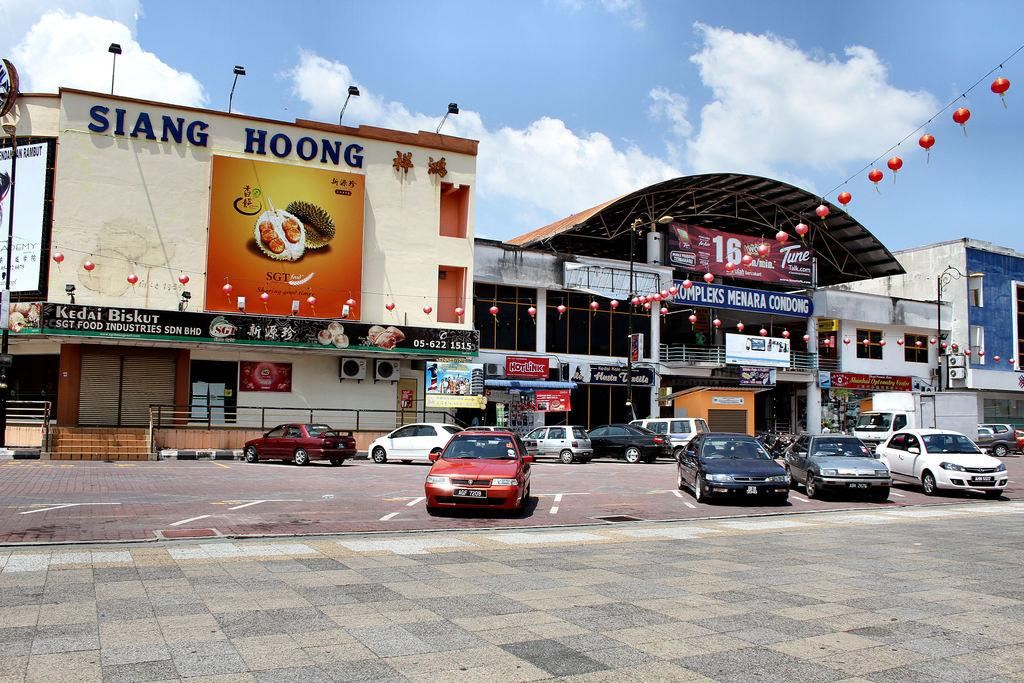What type of vehicles are in the image? There are cars in the image. What is the status of the cars in the image? The cars are parked. Where are the cars located in relation to a nearby establishment? The cars are in front of a shopping complex. What type of gun is visible on the hood of the car in the image? There is no gun visible on the hood of any car in the image. 